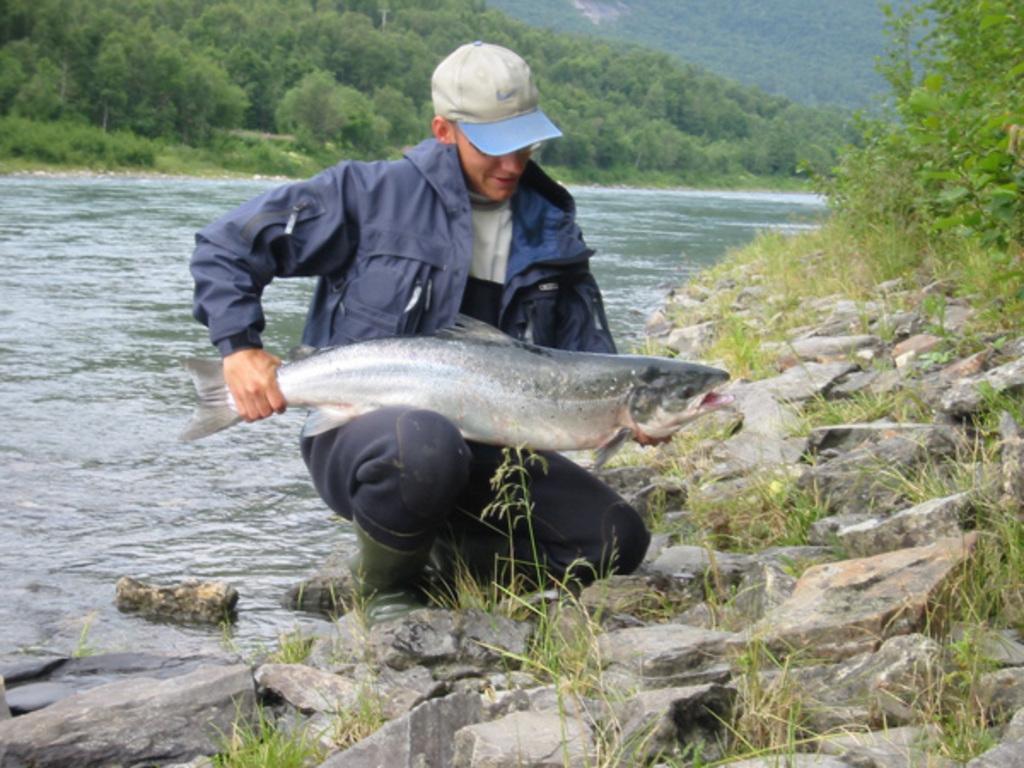Describe this image in one or two sentences. There is a person wearing jacket and cap is holding a fish. He is wearing a boots and is on the side of a river. On the side there are grasses, rocks and plants. Behind him there is a river. In the background there are trees. 